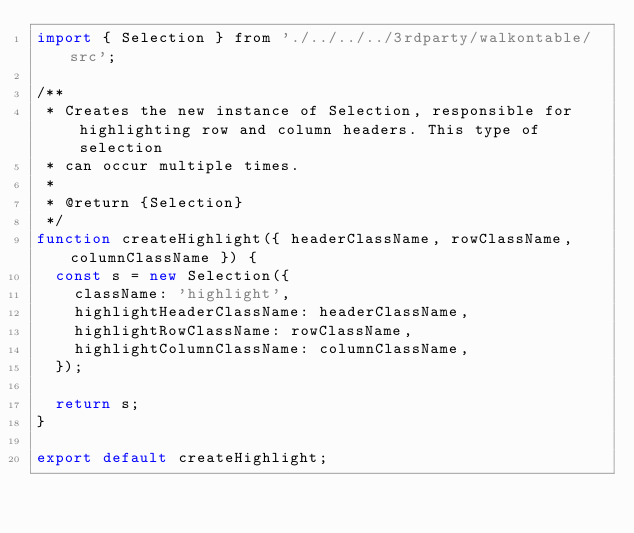<code> <loc_0><loc_0><loc_500><loc_500><_JavaScript_>import { Selection } from './../../../3rdparty/walkontable/src';

/**
 * Creates the new instance of Selection, responsible for highlighting row and column headers. This type of selection
 * can occur multiple times.
 *
 * @return {Selection}
 */
function createHighlight({ headerClassName, rowClassName, columnClassName }) {
  const s = new Selection({
    className: 'highlight',
    highlightHeaderClassName: headerClassName,
    highlightRowClassName: rowClassName,
    highlightColumnClassName: columnClassName,
  });

  return s;
}

export default createHighlight;
</code> 